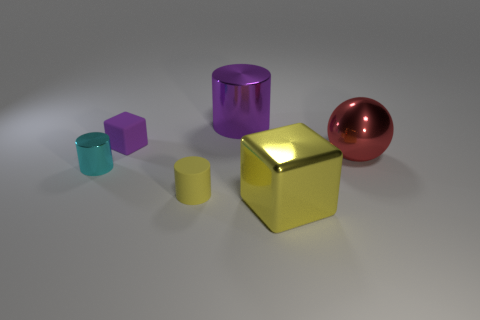Are there any small purple blocks on the left side of the tiny yellow cylinder?
Make the answer very short. Yes. How many purple cylinders are there?
Provide a short and direct response. 1. How many tiny purple cubes are on the right side of the object that is right of the big yellow object?
Offer a very short reply. 0. There is a ball; does it have the same color as the small cylinder to the left of the purple block?
Offer a very short reply. No. What number of other large yellow objects have the same shape as the large yellow metallic thing?
Provide a succinct answer. 0. What is the material of the large object left of the big yellow block?
Offer a terse response. Metal. Do the purple object in front of the purple metal cylinder and the small yellow thing have the same shape?
Offer a terse response. No. Are there any purple rubber objects that have the same size as the yellow matte object?
Provide a succinct answer. Yes. Does the yellow matte thing have the same shape as the thing that is behind the purple matte cube?
Offer a terse response. Yes. There is a large shiny object that is the same color as the tiny matte block; what is its shape?
Provide a succinct answer. Cylinder. 